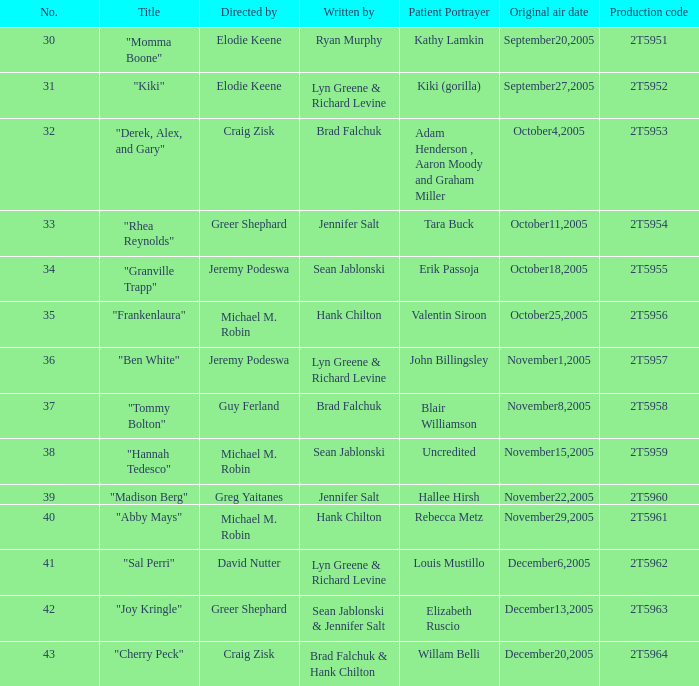Who were the writers for the episode titled "Ben White"? Lyn Greene & Richard Levine. Would you be able to parse every entry in this table? {'header': ['No.', 'Title', 'Directed by', 'Written by', 'Patient Portrayer', 'Original air date', 'Production code'], 'rows': [['30', '"Momma Boone"', 'Elodie Keene', 'Ryan Murphy', 'Kathy Lamkin', 'September20,2005', '2T5951'], ['31', '"Kiki"', 'Elodie Keene', 'Lyn Greene & Richard Levine', 'Kiki (gorilla)', 'September27,2005', '2T5952'], ['32', '"Derek, Alex, and Gary"', 'Craig Zisk', 'Brad Falchuk', 'Adam Henderson , Aaron Moody and Graham Miller', 'October4,2005', '2T5953'], ['33', '"Rhea Reynolds"', 'Greer Shephard', 'Jennifer Salt', 'Tara Buck', 'October11,2005', '2T5954'], ['34', '"Granville Trapp"', 'Jeremy Podeswa', 'Sean Jablonski', 'Erik Passoja', 'October18,2005', '2T5955'], ['35', '"Frankenlaura"', 'Michael M. Robin', 'Hank Chilton', 'Valentin Siroon', 'October25,2005', '2T5956'], ['36', '"Ben White"', 'Jeremy Podeswa', 'Lyn Greene & Richard Levine', 'John Billingsley', 'November1,2005', '2T5957'], ['37', '"Tommy Bolton"', 'Guy Ferland', 'Brad Falchuk', 'Blair Williamson', 'November8,2005', '2T5958'], ['38', '"Hannah Tedesco"', 'Michael M. Robin', 'Sean Jablonski', 'Uncredited', 'November15,2005', '2T5959'], ['39', '"Madison Berg"', 'Greg Yaitanes', 'Jennifer Salt', 'Hallee Hirsh', 'November22,2005', '2T5960'], ['40', '"Abby Mays"', 'Michael M. Robin', 'Hank Chilton', 'Rebecca Metz', 'November29,2005', '2T5961'], ['41', '"Sal Perri"', 'David Nutter', 'Lyn Greene & Richard Levine', 'Louis Mustillo', 'December6,2005', '2T5962'], ['42', '"Joy Kringle"', 'Greer Shephard', 'Sean Jablonski & Jennifer Salt', 'Elizabeth Ruscio', 'December13,2005', '2T5963'], ['43', '"Cherry Peck"', 'Craig Zisk', 'Brad Falchuk & Hank Chilton', 'Willam Belli', 'December20,2005', '2T5964']]} 